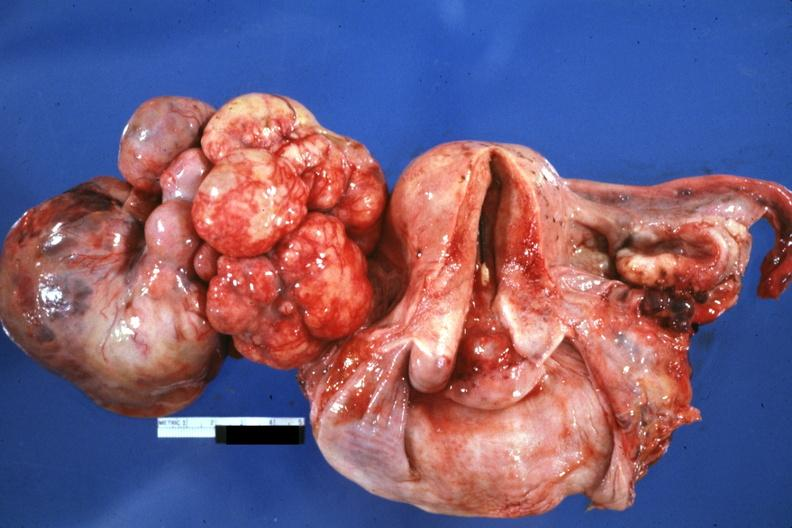does syndactyly show large mass lobular tumor lung primary?
Answer the question using a single word or phrase. No 